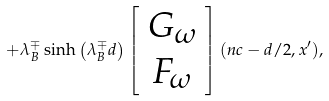<formula> <loc_0><loc_0><loc_500><loc_500>+ \lambda _ { B } ^ { \mp } \sinh \left ( \lambda _ { B } ^ { \mp } d \right ) \left [ \begin{array} { c } G _ { \omega } \\ F _ { \omega } \end{array} \right ] ( n c - d / 2 , x ^ { \prime } ) ,</formula> 